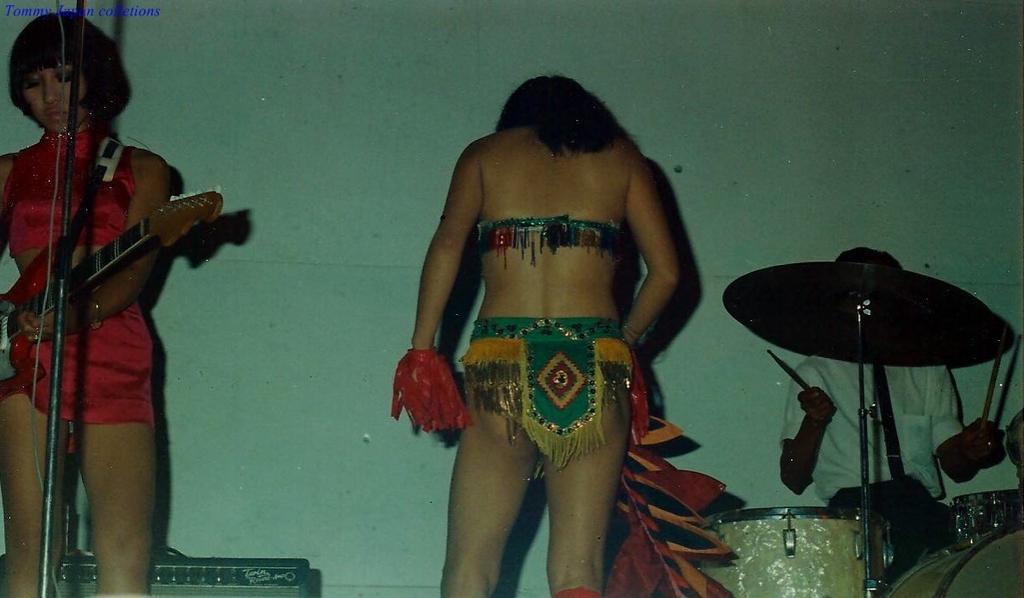How would you summarize this image in a sentence or two? In the middle of the image a person is standing and holding something in hands. Bottom right side of the image a person is sitting and playing drums. Bottom left side of the image a woman is standing and playing guitar. Behind them there is a wall. 